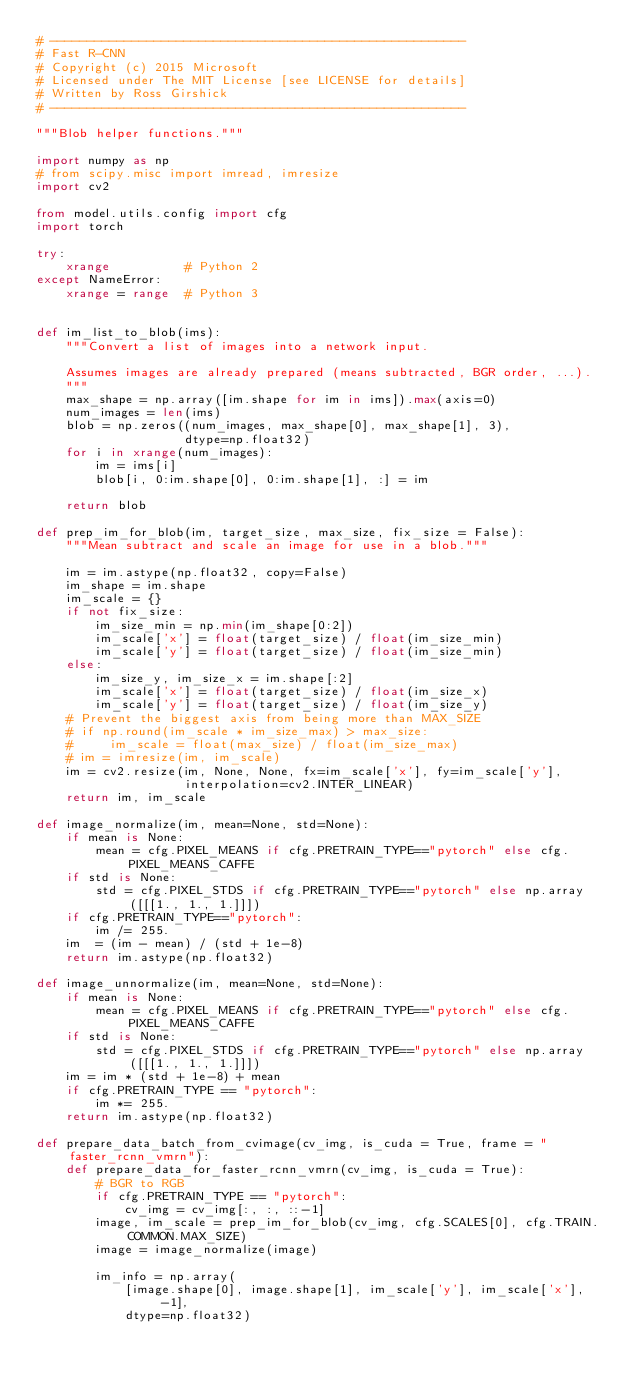<code> <loc_0><loc_0><loc_500><loc_500><_Python_># --------------------------------------------------------
# Fast R-CNN
# Copyright (c) 2015 Microsoft
# Licensed under The MIT License [see LICENSE for details]
# Written by Ross Girshick
# --------------------------------------------------------

"""Blob helper functions."""

import numpy as np
# from scipy.misc import imread, imresize
import cv2

from model.utils.config import cfg
import torch

try:
    xrange          # Python 2
except NameError:
    xrange = range  # Python 3


def im_list_to_blob(ims):
    """Convert a list of images into a network input.

    Assumes images are already prepared (means subtracted, BGR order, ...).
    """
    max_shape = np.array([im.shape for im in ims]).max(axis=0)
    num_images = len(ims)
    blob = np.zeros((num_images, max_shape[0], max_shape[1], 3),
                    dtype=np.float32)
    for i in xrange(num_images):
        im = ims[i]
        blob[i, 0:im.shape[0], 0:im.shape[1], :] = im

    return blob

def prep_im_for_blob(im, target_size, max_size, fix_size = False):
    """Mean subtract and scale an image for use in a blob."""

    im = im.astype(np.float32, copy=False)
    im_shape = im.shape
    im_scale = {}
    if not fix_size:
        im_size_min = np.min(im_shape[0:2])
        im_scale['x'] = float(target_size) / float(im_size_min)
        im_scale['y'] = float(target_size) / float(im_size_min)
    else:
        im_size_y, im_size_x = im.shape[:2]
        im_scale['x'] = float(target_size) / float(im_size_x)
        im_scale['y'] = float(target_size) / float(im_size_y)
    # Prevent the biggest axis from being more than MAX_SIZE
    # if np.round(im_scale * im_size_max) > max_size:
    #     im_scale = float(max_size) / float(im_size_max)
    # im = imresize(im, im_scale)
    im = cv2.resize(im, None, None, fx=im_scale['x'], fy=im_scale['y'],
                    interpolation=cv2.INTER_LINEAR)
    return im, im_scale

def image_normalize(im, mean=None, std=None):
    if mean is None:
        mean = cfg.PIXEL_MEANS if cfg.PRETRAIN_TYPE=="pytorch" else cfg.PIXEL_MEANS_CAFFE
    if std is None:
        std = cfg.PIXEL_STDS if cfg.PRETRAIN_TYPE=="pytorch" else np.array([[[1., 1., 1.]]])
    if cfg.PRETRAIN_TYPE=="pytorch":
        im /= 255.
    im  = (im - mean) / (std + 1e-8)
    return im.astype(np.float32)

def image_unnormalize(im, mean=None, std=None):
    if mean is None:
        mean = cfg.PIXEL_MEANS if cfg.PRETRAIN_TYPE=="pytorch" else cfg.PIXEL_MEANS_CAFFE
    if std is None:
        std = cfg.PIXEL_STDS if cfg.PRETRAIN_TYPE=="pytorch" else np.array([[[1., 1., 1.]]])
    im = im * (std + 1e-8) + mean
    if cfg.PRETRAIN_TYPE == "pytorch":
        im *= 255.
    return im.astype(np.float32)

def prepare_data_batch_from_cvimage(cv_img, is_cuda = True, frame = "faster_rcnn_vmrn"):
    def prepare_data_for_faster_rcnn_vmrn(cv_img, is_cuda = True):
        # BGR to RGB
        if cfg.PRETRAIN_TYPE == "pytorch":
            cv_img = cv_img[:, :, ::-1]
        image, im_scale = prep_im_for_blob(cv_img, cfg.SCALES[0], cfg.TRAIN.COMMON.MAX_SIZE)
        image = image_normalize(image)

        im_info = np.array(
            [image.shape[0], image.shape[1], im_scale['y'], im_scale['x'], -1],
            dtype=np.float32)
</code> 